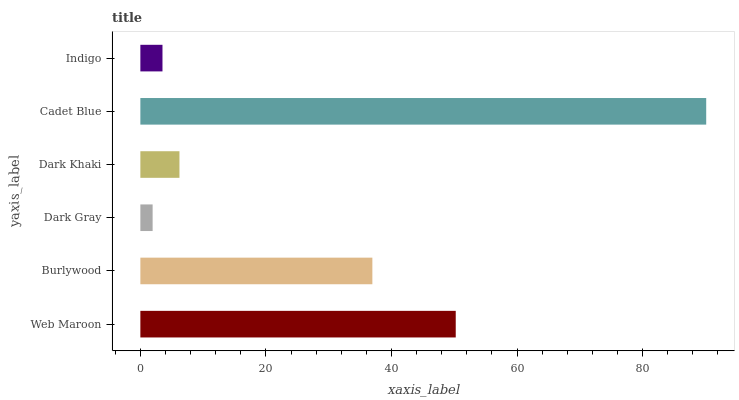Is Dark Gray the minimum?
Answer yes or no. Yes. Is Cadet Blue the maximum?
Answer yes or no. Yes. Is Burlywood the minimum?
Answer yes or no. No. Is Burlywood the maximum?
Answer yes or no. No. Is Web Maroon greater than Burlywood?
Answer yes or no. Yes. Is Burlywood less than Web Maroon?
Answer yes or no. Yes. Is Burlywood greater than Web Maroon?
Answer yes or no. No. Is Web Maroon less than Burlywood?
Answer yes or no. No. Is Burlywood the high median?
Answer yes or no. Yes. Is Dark Khaki the low median?
Answer yes or no. Yes. Is Dark Gray the high median?
Answer yes or no. No. Is Dark Gray the low median?
Answer yes or no. No. 